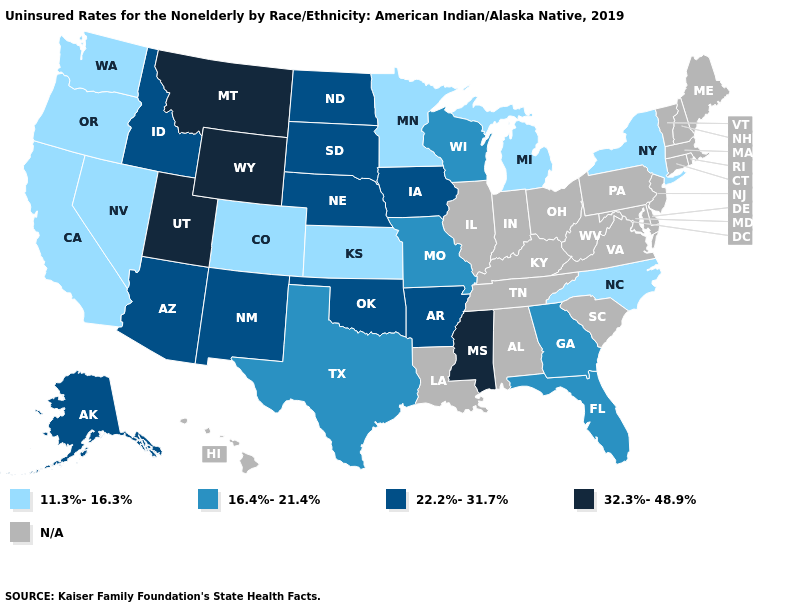What is the lowest value in states that border Pennsylvania?
Write a very short answer. 11.3%-16.3%. Which states have the highest value in the USA?
Be succinct. Mississippi, Montana, Utah, Wyoming. Does the map have missing data?
Give a very brief answer. Yes. Among the states that border Wisconsin , which have the highest value?
Be succinct. Iowa. What is the value of Montana?
Short answer required. 32.3%-48.9%. What is the highest value in states that border Utah?
Write a very short answer. 32.3%-48.9%. Does Mississippi have the highest value in the USA?
Short answer required. Yes. Name the states that have a value in the range 16.4%-21.4%?
Be succinct. Florida, Georgia, Missouri, Texas, Wisconsin. What is the value of Delaware?
Concise answer only. N/A. What is the value of Montana?
Concise answer only. 32.3%-48.9%. Name the states that have a value in the range 16.4%-21.4%?
Answer briefly. Florida, Georgia, Missouri, Texas, Wisconsin. Name the states that have a value in the range N/A?
Give a very brief answer. Alabama, Connecticut, Delaware, Hawaii, Illinois, Indiana, Kentucky, Louisiana, Maine, Maryland, Massachusetts, New Hampshire, New Jersey, Ohio, Pennsylvania, Rhode Island, South Carolina, Tennessee, Vermont, Virginia, West Virginia. Name the states that have a value in the range 22.2%-31.7%?
Answer briefly. Alaska, Arizona, Arkansas, Idaho, Iowa, Nebraska, New Mexico, North Dakota, Oklahoma, South Dakota. How many symbols are there in the legend?
Short answer required. 5. What is the value of Connecticut?
Answer briefly. N/A. 